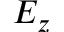Convert formula to latex. <formula><loc_0><loc_0><loc_500><loc_500>E _ { z }</formula> 